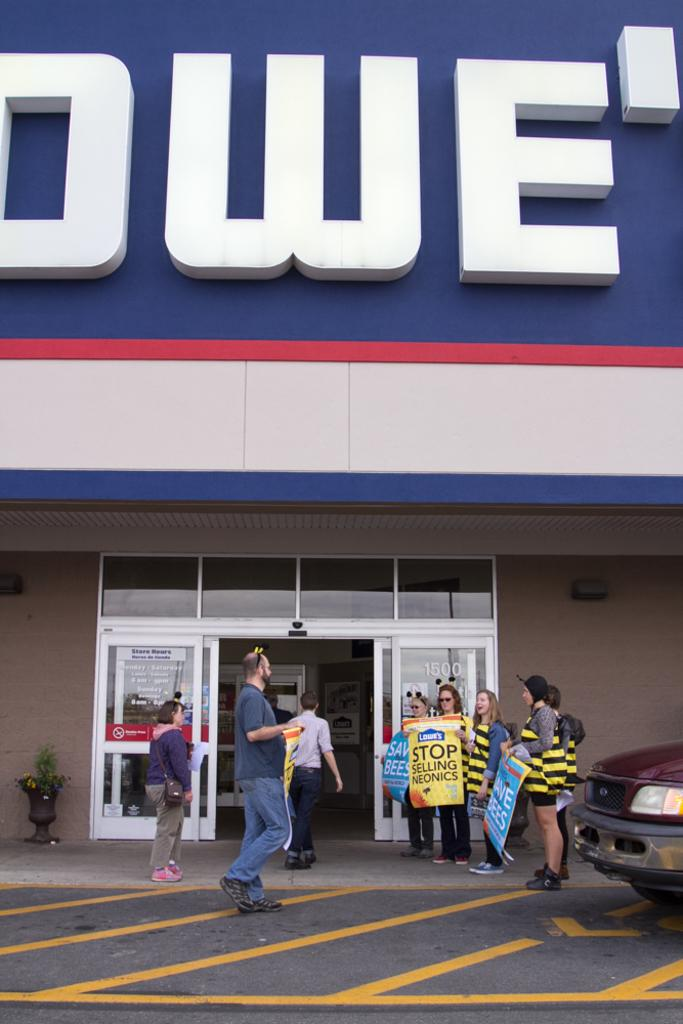Who are the subjects in the image? There are people in the image. What is present on the road in the image? There is a vehicle on the road in the image. What are some people holding in the image? Some people are holding posters in the image. What can be seen in the background of the image? There is a houseplant and a building visible in the background. What type of birds can be seen flying around the creator in the image? There is no creator or birds present in the image. 